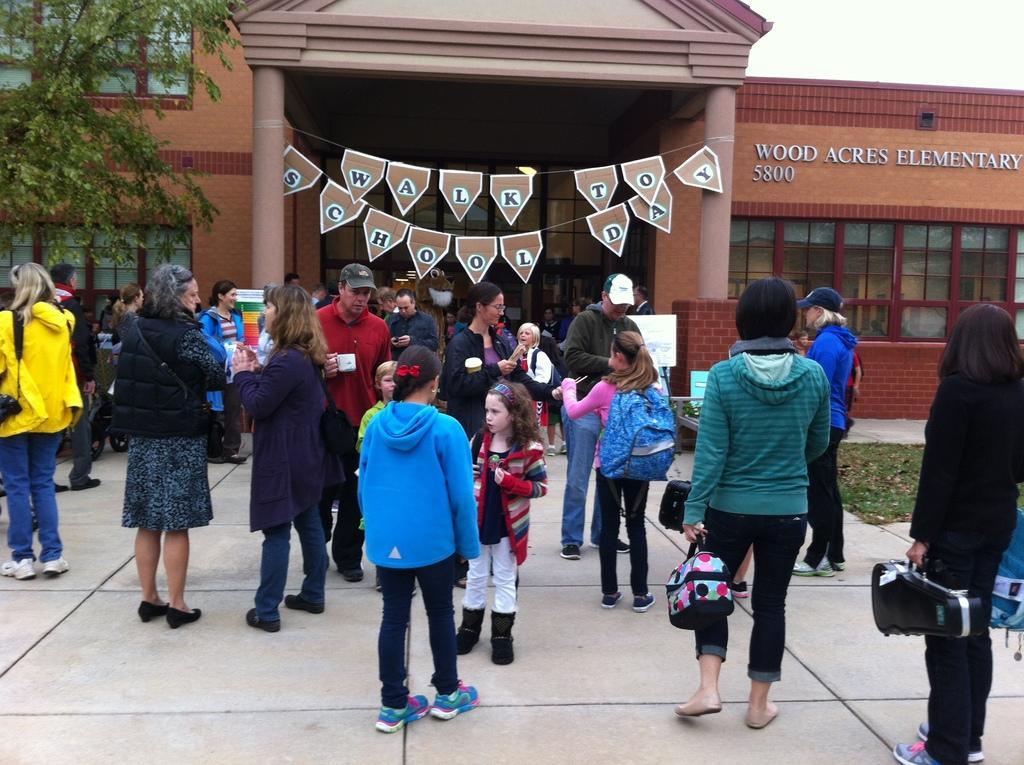How would you summarize this image in a sentence or two? In this picture there are group of people standing and there is a person with green jacket is walking. At the back there is a building and there is a text on the building. On the left side of the image there is a tree and there are boards in front of the building. At the top there is sky. At the bottom there is grass. 